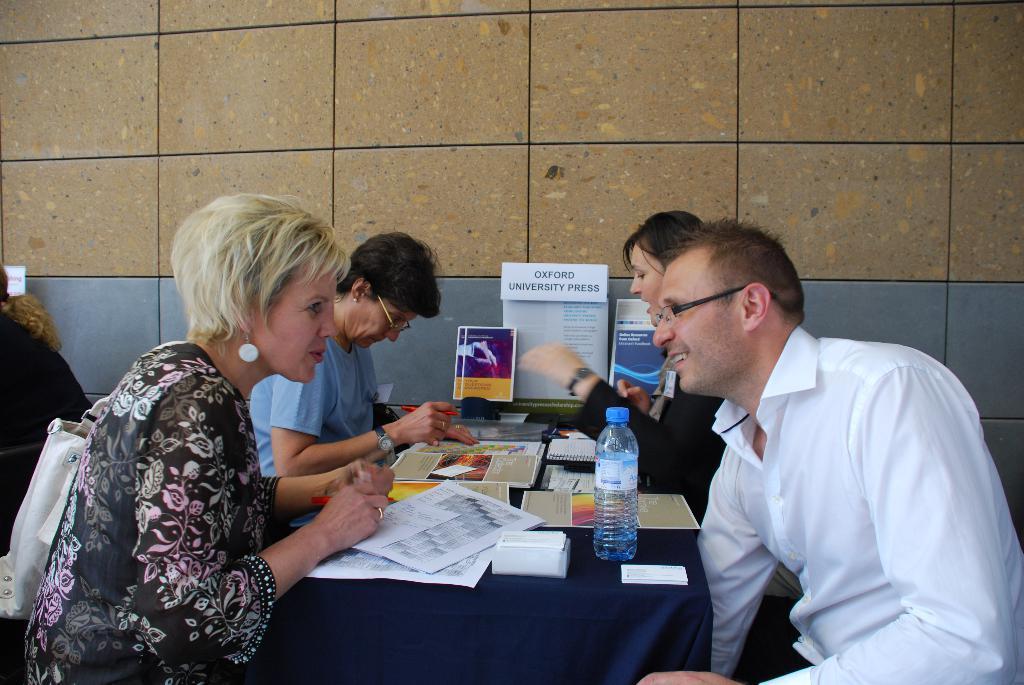Please provide a concise description of this image. In this picture we can see group of people, they are all seated, in front of them we can see a bottle, papers, books and other things on the table, and also we can see few people wore spectacles. 